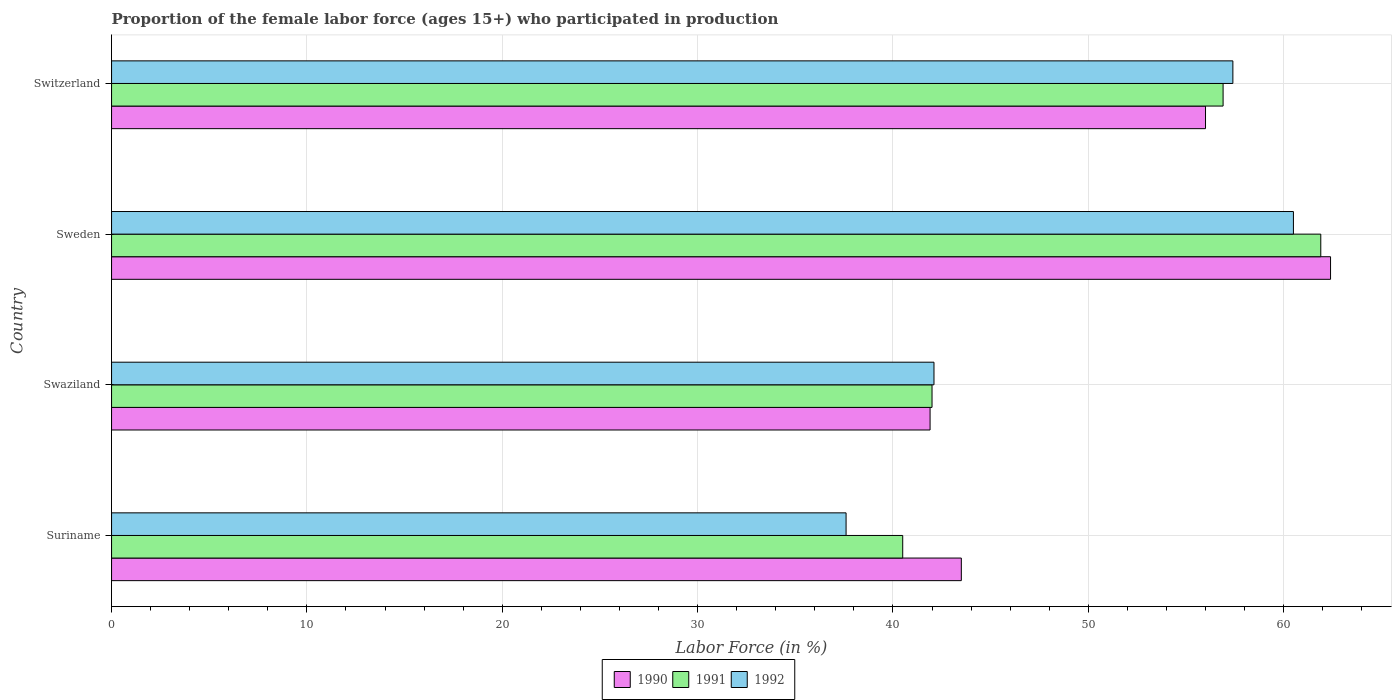What is the label of the 2nd group of bars from the top?
Your answer should be very brief. Sweden. In how many cases, is the number of bars for a given country not equal to the number of legend labels?
Offer a very short reply. 0. What is the proportion of the female labor force who participated in production in 1992 in Sweden?
Provide a short and direct response. 60.5. Across all countries, what is the maximum proportion of the female labor force who participated in production in 1990?
Ensure brevity in your answer.  62.4. Across all countries, what is the minimum proportion of the female labor force who participated in production in 1990?
Your response must be concise. 41.9. In which country was the proportion of the female labor force who participated in production in 1992 minimum?
Make the answer very short. Suriname. What is the total proportion of the female labor force who participated in production in 1992 in the graph?
Your response must be concise. 197.6. What is the difference between the proportion of the female labor force who participated in production in 1990 in Suriname and that in Sweden?
Provide a short and direct response. -18.9. What is the difference between the proportion of the female labor force who participated in production in 1992 in Suriname and the proportion of the female labor force who participated in production in 1991 in Swaziland?
Your response must be concise. -4.4. What is the average proportion of the female labor force who participated in production in 1992 per country?
Keep it short and to the point. 49.4. What is the difference between the proportion of the female labor force who participated in production in 1990 and proportion of the female labor force who participated in production in 1991 in Sweden?
Ensure brevity in your answer.  0.5. In how many countries, is the proportion of the female labor force who participated in production in 1990 greater than 24 %?
Make the answer very short. 4. What is the ratio of the proportion of the female labor force who participated in production in 1992 in Suriname to that in Switzerland?
Ensure brevity in your answer.  0.66. What is the difference between the highest and the second highest proportion of the female labor force who participated in production in 1992?
Offer a very short reply. 3.1. What is the difference between the highest and the lowest proportion of the female labor force who participated in production in 1991?
Offer a very short reply. 21.4. What does the 3rd bar from the top in Sweden represents?
Your response must be concise. 1990. How many bars are there?
Provide a short and direct response. 12. Are all the bars in the graph horizontal?
Ensure brevity in your answer.  Yes. How many countries are there in the graph?
Offer a very short reply. 4. Are the values on the major ticks of X-axis written in scientific E-notation?
Provide a short and direct response. No. Does the graph contain any zero values?
Your answer should be very brief. No. How many legend labels are there?
Provide a succinct answer. 3. How are the legend labels stacked?
Ensure brevity in your answer.  Horizontal. What is the title of the graph?
Provide a short and direct response. Proportion of the female labor force (ages 15+) who participated in production. What is the label or title of the Y-axis?
Make the answer very short. Country. What is the Labor Force (in %) of 1990 in Suriname?
Your answer should be compact. 43.5. What is the Labor Force (in %) in 1991 in Suriname?
Your response must be concise. 40.5. What is the Labor Force (in %) of 1992 in Suriname?
Your answer should be very brief. 37.6. What is the Labor Force (in %) of 1990 in Swaziland?
Offer a terse response. 41.9. What is the Labor Force (in %) of 1991 in Swaziland?
Ensure brevity in your answer.  42. What is the Labor Force (in %) in 1992 in Swaziland?
Your response must be concise. 42.1. What is the Labor Force (in %) of 1990 in Sweden?
Ensure brevity in your answer.  62.4. What is the Labor Force (in %) in 1991 in Sweden?
Give a very brief answer. 61.9. What is the Labor Force (in %) of 1992 in Sweden?
Your answer should be compact. 60.5. What is the Labor Force (in %) of 1991 in Switzerland?
Keep it short and to the point. 56.9. What is the Labor Force (in %) of 1992 in Switzerland?
Provide a short and direct response. 57.4. Across all countries, what is the maximum Labor Force (in %) in 1990?
Provide a short and direct response. 62.4. Across all countries, what is the maximum Labor Force (in %) in 1991?
Keep it short and to the point. 61.9. Across all countries, what is the maximum Labor Force (in %) of 1992?
Provide a short and direct response. 60.5. Across all countries, what is the minimum Labor Force (in %) in 1990?
Make the answer very short. 41.9. Across all countries, what is the minimum Labor Force (in %) in 1991?
Make the answer very short. 40.5. Across all countries, what is the minimum Labor Force (in %) of 1992?
Provide a short and direct response. 37.6. What is the total Labor Force (in %) in 1990 in the graph?
Provide a succinct answer. 203.8. What is the total Labor Force (in %) of 1991 in the graph?
Your answer should be compact. 201.3. What is the total Labor Force (in %) of 1992 in the graph?
Your response must be concise. 197.6. What is the difference between the Labor Force (in %) of 1990 in Suriname and that in Swaziland?
Your response must be concise. 1.6. What is the difference between the Labor Force (in %) of 1991 in Suriname and that in Swaziland?
Offer a terse response. -1.5. What is the difference between the Labor Force (in %) in 1992 in Suriname and that in Swaziland?
Offer a terse response. -4.5. What is the difference between the Labor Force (in %) in 1990 in Suriname and that in Sweden?
Your response must be concise. -18.9. What is the difference between the Labor Force (in %) of 1991 in Suriname and that in Sweden?
Ensure brevity in your answer.  -21.4. What is the difference between the Labor Force (in %) of 1992 in Suriname and that in Sweden?
Ensure brevity in your answer.  -22.9. What is the difference between the Labor Force (in %) of 1991 in Suriname and that in Switzerland?
Give a very brief answer. -16.4. What is the difference between the Labor Force (in %) of 1992 in Suriname and that in Switzerland?
Your response must be concise. -19.8. What is the difference between the Labor Force (in %) in 1990 in Swaziland and that in Sweden?
Provide a succinct answer. -20.5. What is the difference between the Labor Force (in %) in 1991 in Swaziland and that in Sweden?
Your response must be concise. -19.9. What is the difference between the Labor Force (in %) of 1992 in Swaziland and that in Sweden?
Offer a terse response. -18.4. What is the difference between the Labor Force (in %) of 1990 in Swaziland and that in Switzerland?
Provide a succinct answer. -14.1. What is the difference between the Labor Force (in %) in 1991 in Swaziland and that in Switzerland?
Your answer should be very brief. -14.9. What is the difference between the Labor Force (in %) in 1992 in Swaziland and that in Switzerland?
Keep it short and to the point. -15.3. What is the difference between the Labor Force (in %) of 1991 in Sweden and that in Switzerland?
Ensure brevity in your answer.  5. What is the difference between the Labor Force (in %) in 1992 in Sweden and that in Switzerland?
Your answer should be very brief. 3.1. What is the difference between the Labor Force (in %) of 1990 in Suriname and the Labor Force (in %) of 1992 in Swaziland?
Offer a terse response. 1.4. What is the difference between the Labor Force (in %) of 1990 in Suriname and the Labor Force (in %) of 1991 in Sweden?
Your answer should be compact. -18.4. What is the difference between the Labor Force (in %) of 1990 in Suriname and the Labor Force (in %) of 1992 in Sweden?
Your answer should be very brief. -17. What is the difference between the Labor Force (in %) of 1991 in Suriname and the Labor Force (in %) of 1992 in Sweden?
Your answer should be very brief. -20. What is the difference between the Labor Force (in %) in 1990 in Suriname and the Labor Force (in %) in 1992 in Switzerland?
Your response must be concise. -13.9. What is the difference between the Labor Force (in %) of 1991 in Suriname and the Labor Force (in %) of 1992 in Switzerland?
Provide a short and direct response. -16.9. What is the difference between the Labor Force (in %) of 1990 in Swaziland and the Labor Force (in %) of 1992 in Sweden?
Provide a short and direct response. -18.6. What is the difference between the Labor Force (in %) in 1991 in Swaziland and the Labor Force (in %) in 1992 in Sweden?
Give a very brief answer. -18.5. What is the difference between the Labor Force (in %) in 1990 in Swaziland and the Labor Force (in %) in 1991 in Switzerland?
Your answer should be very brief. -15. What is the difference between the Labor Force (in %) in 1990 in Swaziland and the Labor Force (in %) in 1992 in Switzerland?
Provide a succinct answer. -15.5. What is the difference between the Labor Force (in %) in 1991 in Swaziland and the Labor Force (in %) in 1992 in Switzerland?
Your answer should be very brief. -15.4. What is the difference between the Labor Force (in %) in 1990 in Sweden and the Labor Force (in %) in 1992 in Switzerland?
Ensure brevity in your answer.  5. What is the average Labor Force (in %) of 1990 per country?
Your response must be concise. 50.95. What is the average Labor Force (in %) of 1991 per country?
Keep it short and to the point. 50.33. What is the average Labor Force (in %) in 1992 per country?
Provide a succinct answer. 49.4. What is the difference between the Labor Force (in %) in 1990 and Labor Force (in %) in 1991 in Suriname?
Offer a very short reply. 3. What is the difference between the Labor Force (in %) of 1990 and Labor Force (in %) of 1992 in Swaziland?
Your answer should be very brief. -0.2. What is the difference between the Labor Force (in %) in 1990 and Labor Force (in %) in 1991 in Sweden?
Provide a succinct answer. 0.5. What is the difference between the Labor Force (in %) in 1990 and Labor Force (in %) in 1992 in Sweden?
Provide a short and direct response. 1.9. What is the difference between the Labor Force (in %) of 1990 and Labor Force (in %) of 1991 in Switzerland?
Your answer should be very brief. -0.9. What is the ratio of the Labor Force (in %) in 1990 in Suriname to that in Swaziland?
Ensure brevity in your answer.  1.04. What is the ratio of the Labor Force (in %) in 1991 in Suriname to that in Swaziland?
Offer a terse response. 0.96. What is the ratio of the Labor Force (in %) in 1992 in Suriname to that in Swaziland?
Provide a succinct answer. 0.89. What is the ratio of the Labor Force (in %) in 1990 in Suriname to that in Sweden?
Give a very brief answer. 0.7. What is the ratio of the Labor Force (in %) in 1991 in Suriname to that in Sweden?
Your answer should be very brief. 0.65. What is the ratio of the Labor Force (in %) in 1992 in Suriname to that in Sweden?
Provide a succinct answer. 0.62. What is the ratio of the Labor Force (in %) in 1990 in Suriname to that in Switzerland?
Offer a terse response. 0.78. What is the ratio of the Labor Force (in %) of 1991 in Suriname to that in Switzerland?
Give a very brief answer. 0.71. What is the ratio of the Labor Force (in %) in 1992 in Suriname to that in Switzerland?
Provide a short and direct response. 0.66. What is the ratio of the Labor Force (in %) of 1990 in Swaziland to that in Sweden?
Your answer should be compact. 0.67. What is the ratio of the Labor Force (in %) of 1991 in Swaziland to that in Sweden?
Offer a terse response. 0.68. What is the ratio of the Labor Force (in %) of 1992 in Swaziland to that in Sweden?
Ensure brevity in your answer.  0.7. What is the ratio of the Labor Force (in %) of 1990 in Swaziland to that in Switzerland?
Offer a terse response. 0.75. What is the ratio of the Labor Force (in %) of 1991 in Swaziland to that in Switzerland?
Make the answer very short. 0.74. What is the ratio of the Labor Force (in %) of 1992 in Swaziland to that in Switzerland?
Your response must be concise. 0.73. What is the ratio of the Labor Force (in %) of 1990 in Sweden to that in Switzerland?
Your response must be concise. 1.11. What is the ratio of the Labor Force (in %) of 1991 in Sweden to that in Switzerland?
Your response must be concise. 1.09. What is the ratio of the Labor Force (in %) in 1992 in Sweden to that in Switzerland?
Provide a short and direct response. 1.05. What is the difference between the highest and the second highest Labor Force (in %) in 1991?
Make the answer very short. 5. What is the difference between the highest and the second highest Labor Force (in %) of 1992?
Offer a very short reply. 3.1. What is the difference between the highest and the lowest Labor Force (in %) in 1990?
Keep it short and to the point. 20.5. What is the difference between the highest and the lowest Labor Force (in %) of 1991?
Keep it short and to the point. 21.4. What is the difference between the highest and the lowest Labor Force (in %) of 1992?
Provide a short and direct response. 22.9. 